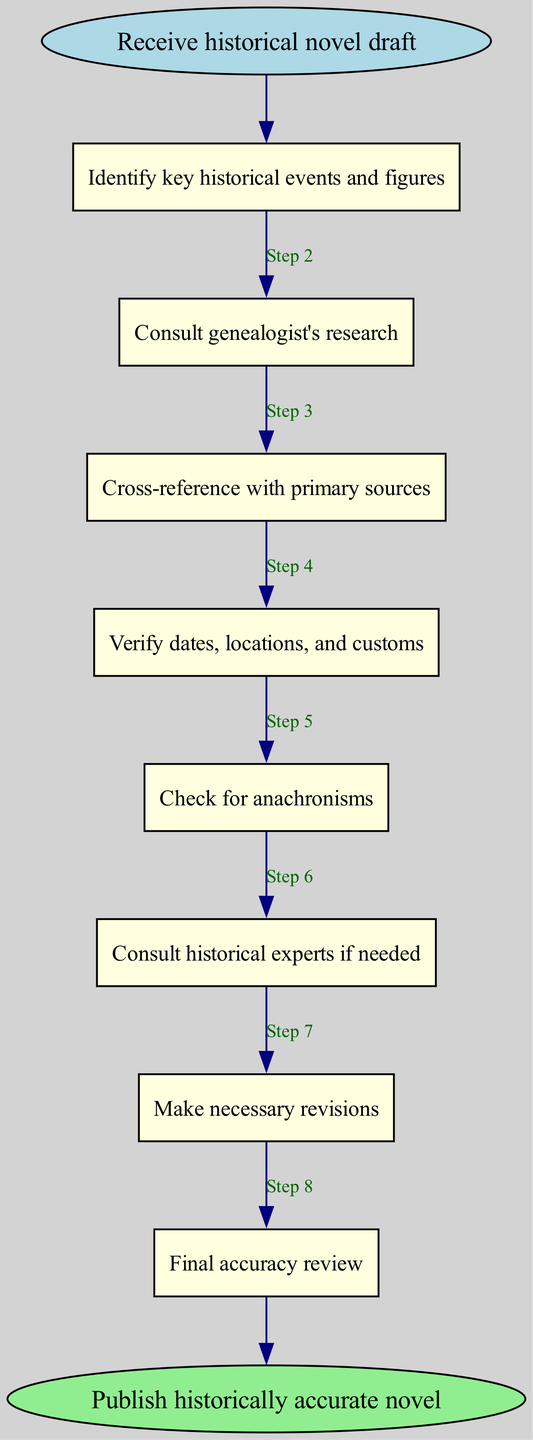What is the first step in the fact-checking procedure? The first step in the diagram is labeled as "Receive historical novel draft," which is the starting point of the process.
Answer: Receive historical novel draft How many steps are there in the diagram? The diagram contains 8 process steps between the start and the end nodes, as indicated by the sequence of elements leading to the final step.
Answer: 8 What is the last step before publication? The last step in the flow chart before reaching the publication status is "Final accuracy review," which is essential to ensure that everything is correct.
Answer: Final accuracy review Which step involves consulting external sources? The step labeled "Consult genealogist's research" indicates when external research is included in the fact-checking process, which relies on genealogists' expertise.
Answer: Consult genealogist's research What happens after verifying dates, locations, and customs? Following the verification of dates, locations, and customs, the next step is checking for anachronisms, ensuring that nothing contradicts the historical timeline.
Answer: Check for anachronisms What is the function of consulting historical experts in the diagram? Consulting historical experts serves as a step when clarification is needed in the fact-checking procedure, providing additional insights and ensuring accuracy in the narrative.
Answer: Consult historical experts if needed Which step comes after making necessary revisions? After making necessary revisions, the next step to be taken is "Final accuracy review," which serves as the last check before publication.
Answer: Final accuracy review What does the next step after identifying key historical events and figures entail? After identifying key historical events and figures, the subsequent action is to consult genealogist's research, linking the initial identification of events to deeper research.
Answer: Consult genealogist's research 